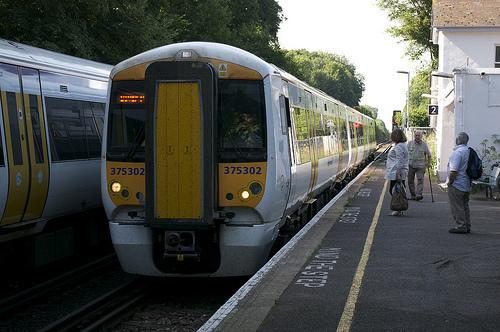Identify the primary mode of transportation in the image and mention its color. The primary mode of transportation is a yellow and white train on the tracks. Provide an overview of the environment in the image. The image shows a train station with a colorful train, passengers, a bench, buildings and several trees. Mention the actions of the people near the train. There are commuters waiting on the train platform, a woman holding a backpack, and a man walking with a cane. Comment on the appearance of the building and the bench in the picture. There is a white building next to the platform and an empty bench near the building. Describe the appearance and color of the train doors. The train doors are closed and are yellow and silver in color. Describe any safety feature present near the train or the platform. There is a painted yellow safety line on the edge of the platform. State the number that can be seen in the image and the color of the text. The track number is 2 and it is in blue color. Highlight one interesting detail about the train front and its windows. The front of the train is orange and has tinted windows. Describe the unique element on the front of the train. There is a caution sign on the front of the train. State the location of the trees and their general appearance. The trees with green leaves are located next to the train. 